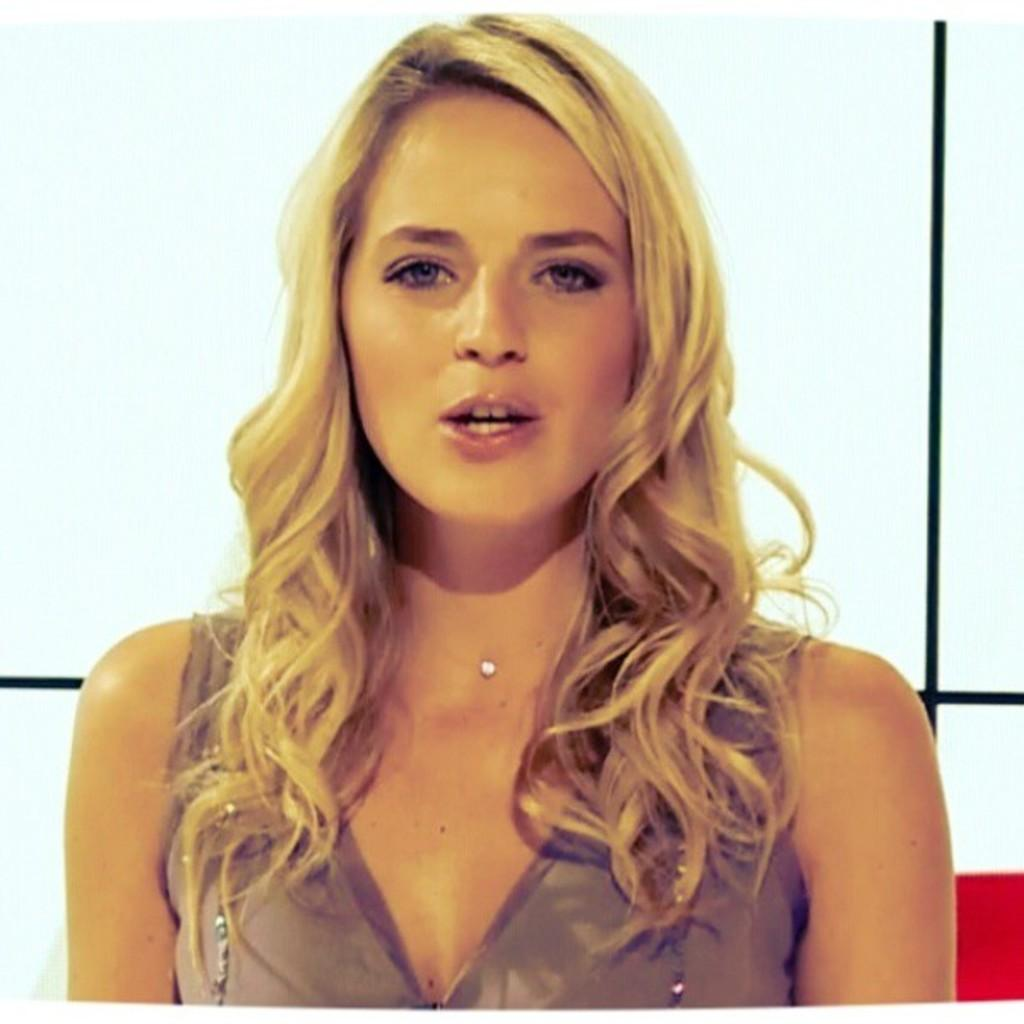Who is the main subject in the image? There is a girl in the center of the image. What can be seen in the background of the image? There is a poster in the background of the image. What type of lip can be seen on the girl's face in the image? There is no lip visible on the girl's face in the image. What emotion is the girl expressing in the image? The image does not show any specific emotion or fear on the girl's face. 